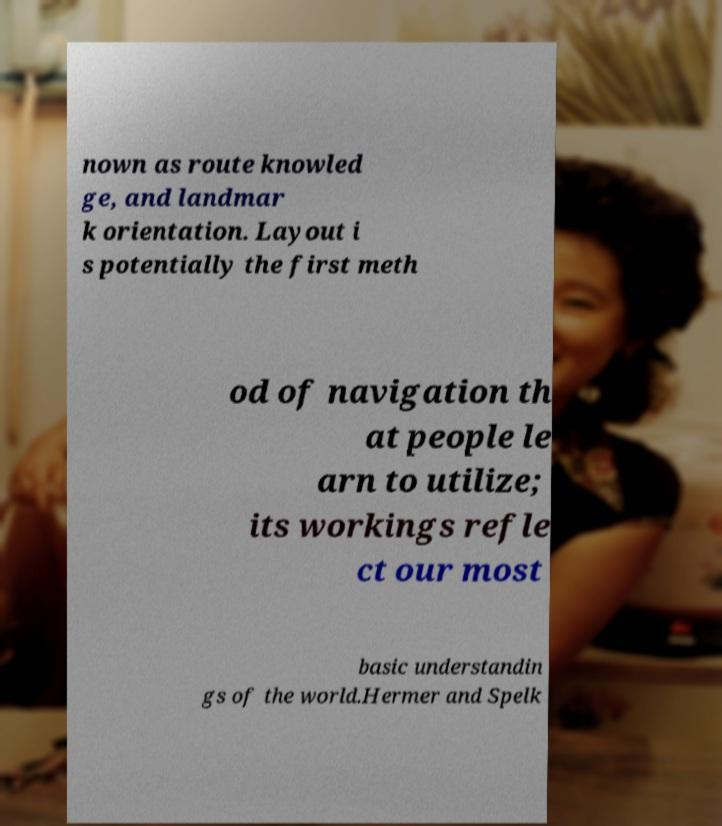Could you assist in decoding the text presented in this image and type it out clearly? nown as route knowled ge, and landmar k orientation. Layout i s potentially the first meth od of navigation th at people le arn to utilize; its workings refle ct our most basic understandin gs of the world.Hermer and Spelk 